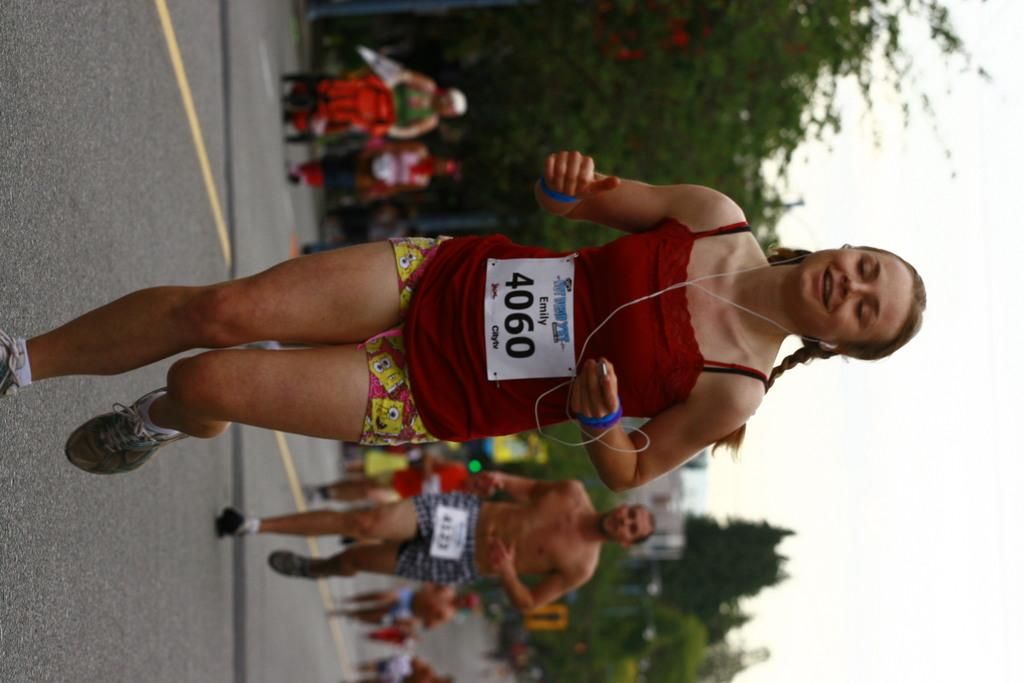<image>
Describe the image concisely. A runner with BIB number 4060 in the foreground of several others during a marathon. 